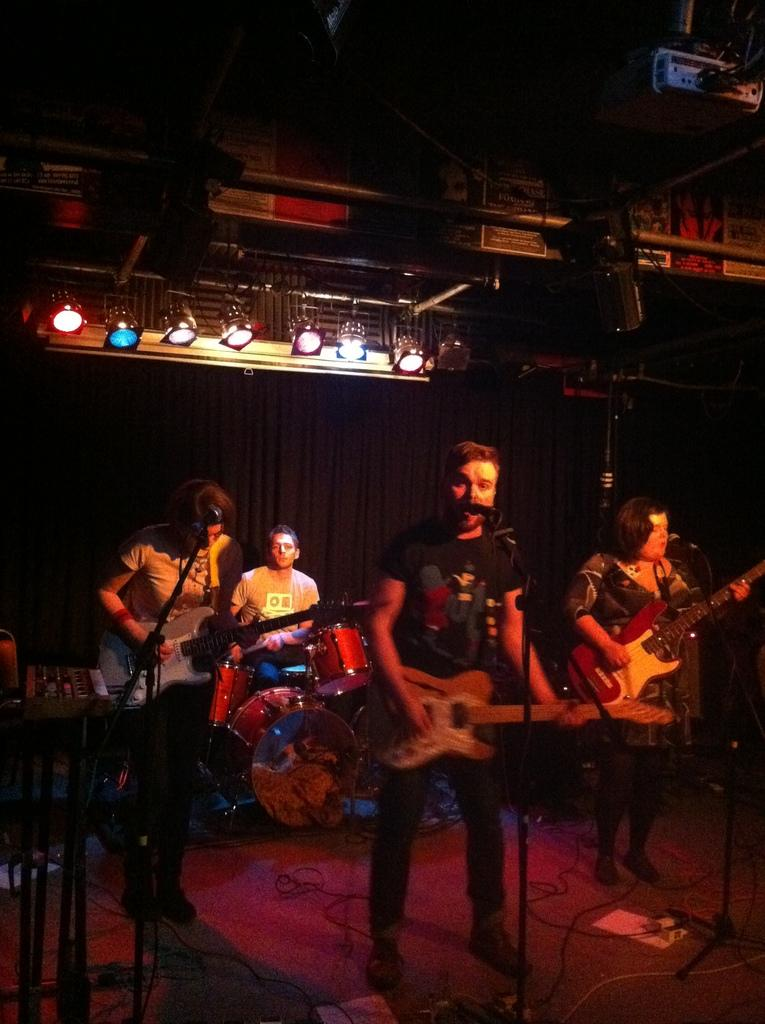What type of performance is happening in the image? There is a rock band performing on stage. How many members of the band are playing guitars? Three members of the band are playing guitars. What instrument is the fourth member of the band playing? The fourth member of the band is playing drums. What can be seen above the stage in the image? There are lights on top, presumably illuminating the stage. What holiday is being celebrated in the image? There is no indication of a holiday being celebrated in the image; it features a rock band performing on stage. What type of agreement is being discussed by the band members in the image? There is no discussion or agreement visible in the image; it focuses on the band's performance. 